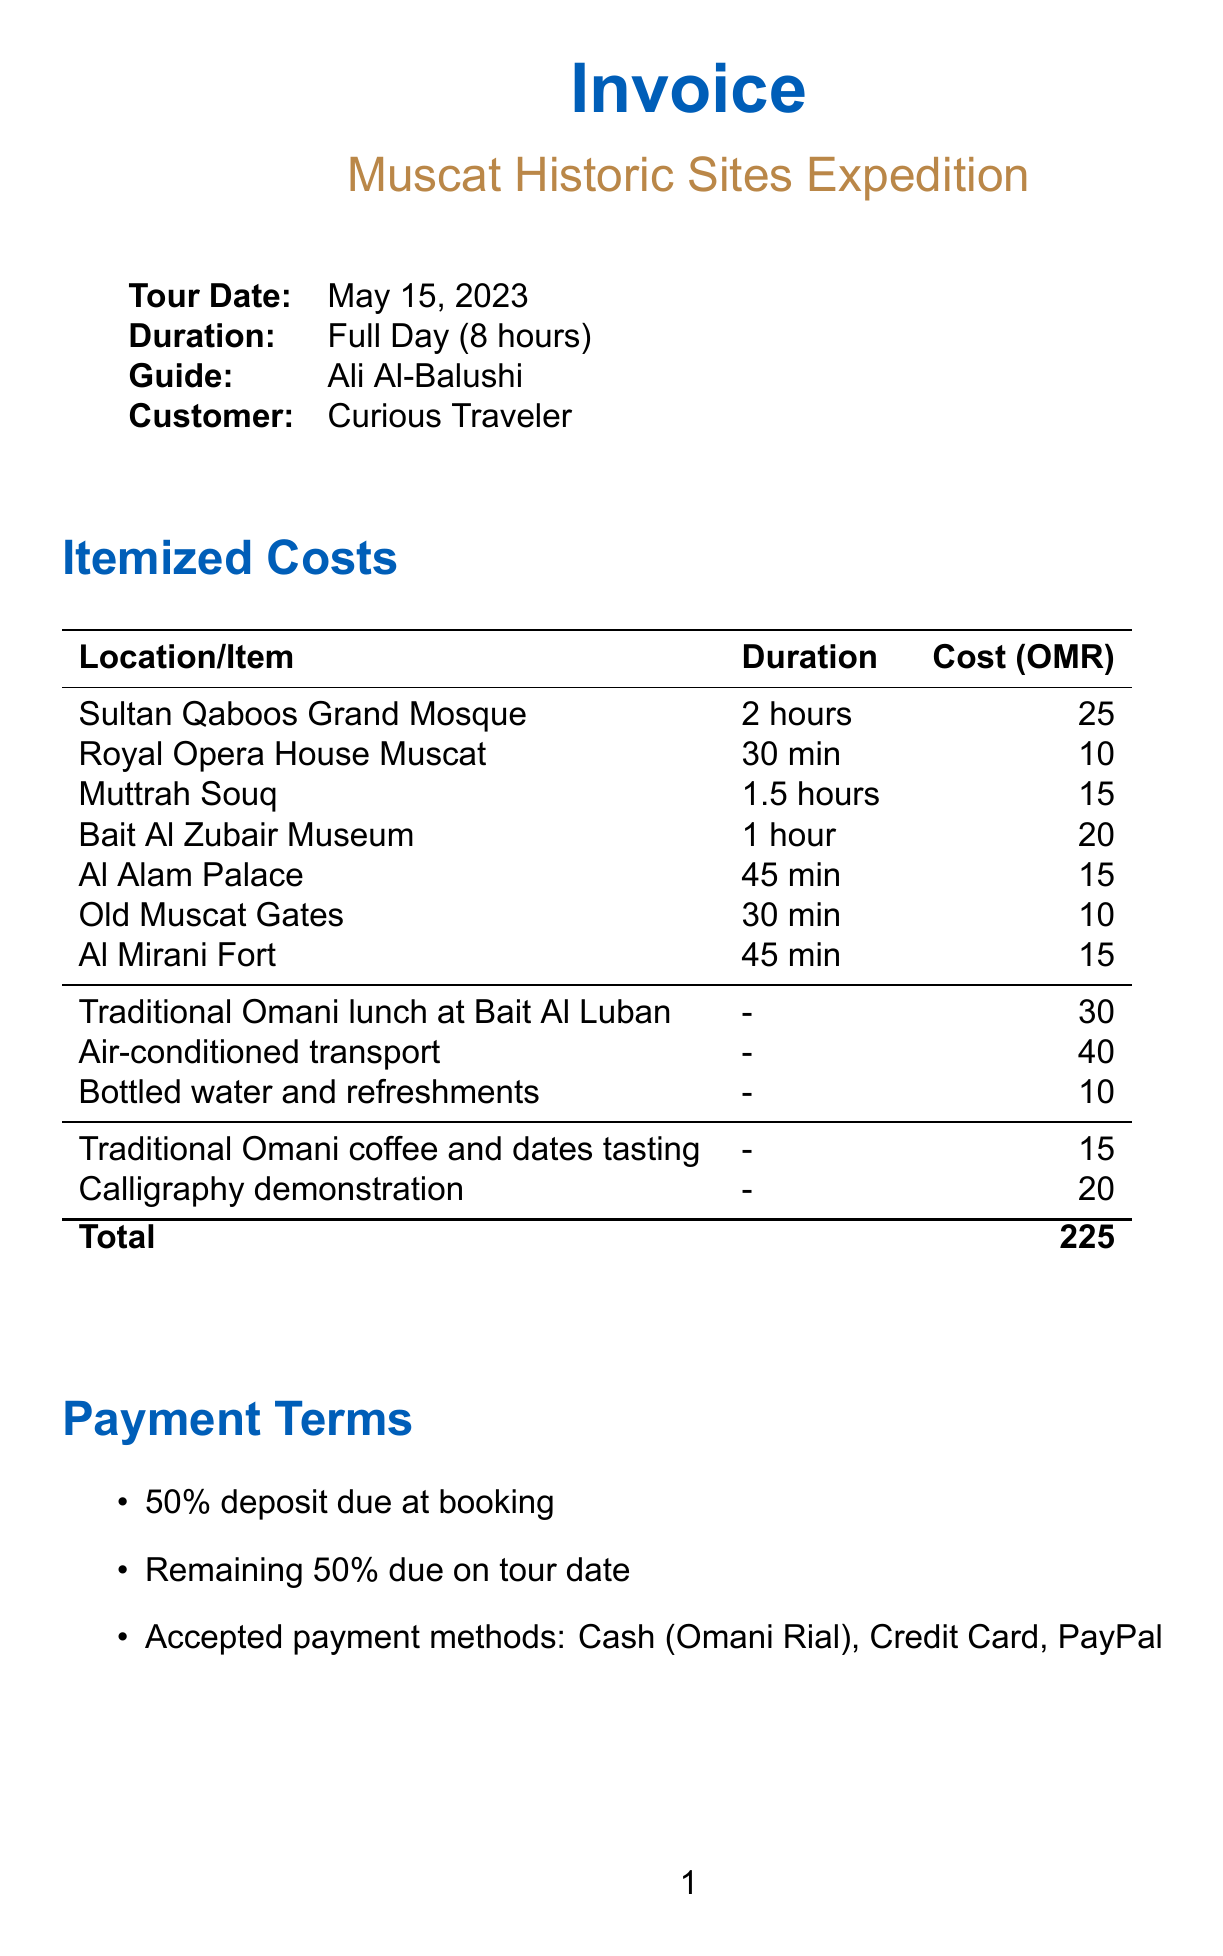What is the tour name? The document states the tour name under invoice details, which is "Muscat Historic Sites Expedition."
Answer: Muscat Historic Sites Expedition Who is the guide for the tour? The guide's name is found in the invoice details, listed as "Ali Al-Balushi."
Answer: Ali Al-Balushi What is the duration of the tour? The duration of the tour is specified in the invoice details as "Full Day (8 hours)."
Answer: Full Day (8 hours) How much does the guided tour at the Sultan Qaboos Grand Mosque cost? The cost for the guided tour of Sultan Qaboos Grand Mosque is listed under itemized costs, which is 25 OMR.
Answer: 25 What is the total cost of the invoice? The total cost is shown at the bottom of the itemized costs, which sums to 225 OMR.
Answer: 225 What percentage of the total cost is required as a deposit? The payment terms state that a 50% deposit is due at booking.
Answer: 50% How long before the tour date can a customer cancel for a full refund? The cancellation policy specifies that a full refund is available if canceled 48 hours before the tour date.
Answer: 48 hours What additional cultural experience is offered at Bait Al Zubair Museum? The document mentions a "Calligraphy demonstration," which is the additional cultural experience.
Answer: Calligraphy demonstration What mode of transport is provided between sites? The invoice lists "Air-conditioned transport between sites" as an additional cost item under itemized costs.
Answer: Air-conditioned transport 